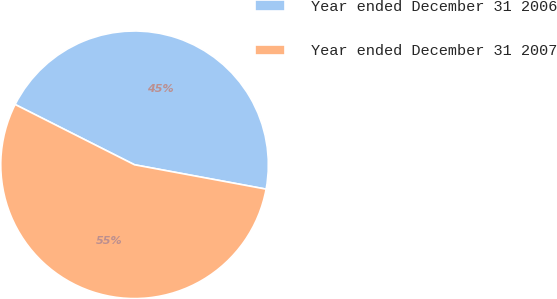Convert chart to OTSL. <chart><loc_0><loc_0><loc_500><loc_500><pie_chart><fcel>Year ended December 31 2006<fcel>Year ended December 31 2007<nl><fcel>45.47%<fcel>54.53%<nl></chart> 